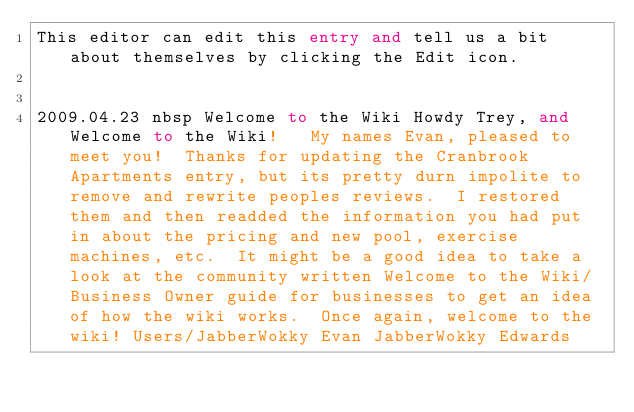<code> <loc_0><loc_0><loc_500><loc_500><_FORTRAN_>This editor can edit this entry and tell us a bit about themselves by clicking the Edit icon.


2009.04.23 nbsp Welcome to the Wiki Howdy Trey, and Welcome to the Wiki!   My names Evan, pleased to meet you!  Thanks for updating the Cranbrook Apartments entry, but its pretty durn impolite to remove and rewrite peoples reviews.  I restored them and then readded the information you had put in about the pricing and new pool, exercise machines, etc.  It might be a good idea to take a look at the community written Welcome to the Wiki/Business Owner guide for businesses to get an idea of how the wiki works.  Once again, welcome to the wiki! Users/JabberWokky Evan JabberWokky Edwards
</code> 